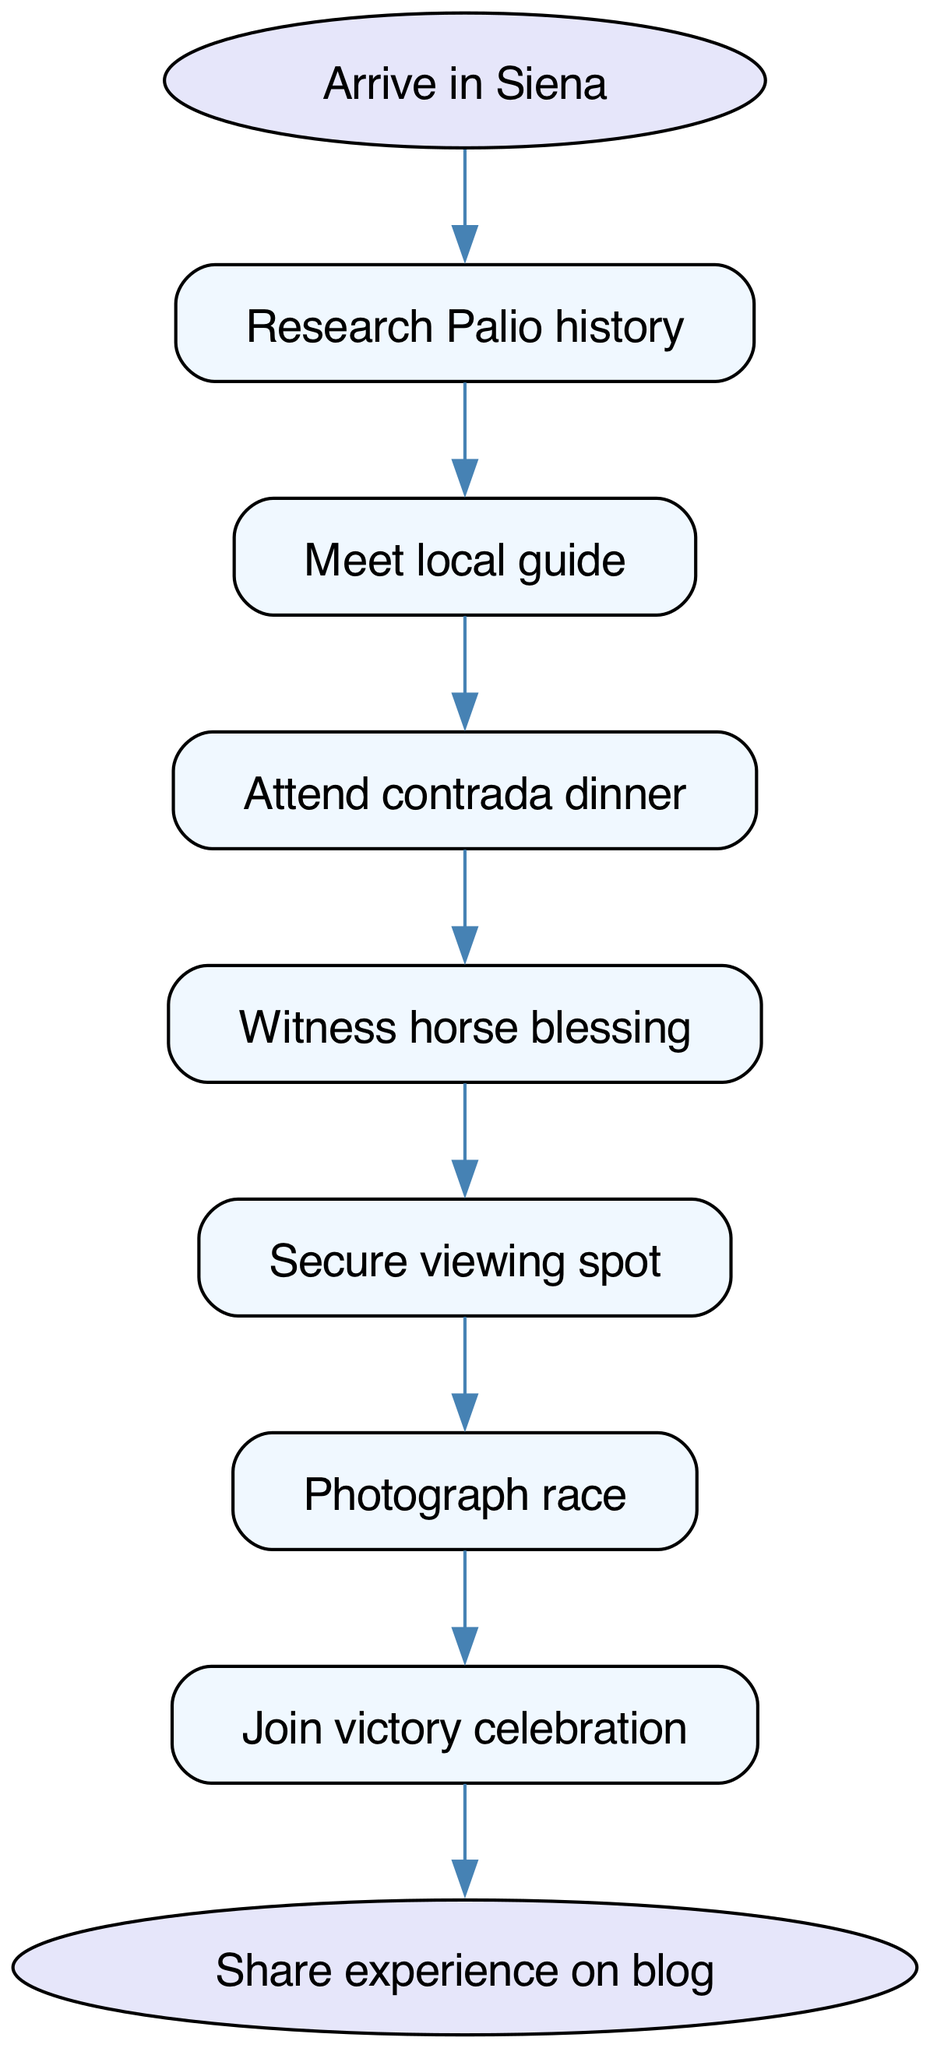What is the starting point of the experience? The diagram indicates that the starting point, represented by the "start" node, is "Arrive in Siena".
Answer: Arrive in Siena What is the last step in the process? According to the diagram, the final step, represented by the "end" node, is "Share experience on blog".
Answer: Share experience on blog How many steps are there in total? By counting all the nodes except the start and end nodes, we see there are 7 other steps, making a total of 9.
Answer: 9 Which activity comes immediately after meeting the local guide? The diagram shows that after "Meet local guide", the next step is "Attend contrada dinner".
Answer: Attend contrada dinner What is the relationship between the horse blessing and securing a viewing spot? The diagram shows that "Witness horse blessing" directly leads to "Secure viewing spot", indicating a sequential relationship.
Answer: Sequential relationship What step occurs before photographing the race? The diagram indicates that the step preceding "Photograph race" is "Secure viewing spot", establishing a clear order.
Answer: Secure viewing spot How many edges connect different steps in the diagram? Each connection (or edge) between nodes represents a movement to the next step, and counting them reveals there are 8 edges.
Answer: 8 What action follows the victory celebration? According to the diagram, "Join victory celebration" leads directly to "Share experience on blog", showing this as the subsequent action.
Answer: Share experience on blog What is the primary objective of the flowchart? The flowchart visually outlines the sequence of activities leading up to participating in the Palio di Siena and sharing the experience.
Answer: Participating in the Palio di Siena 